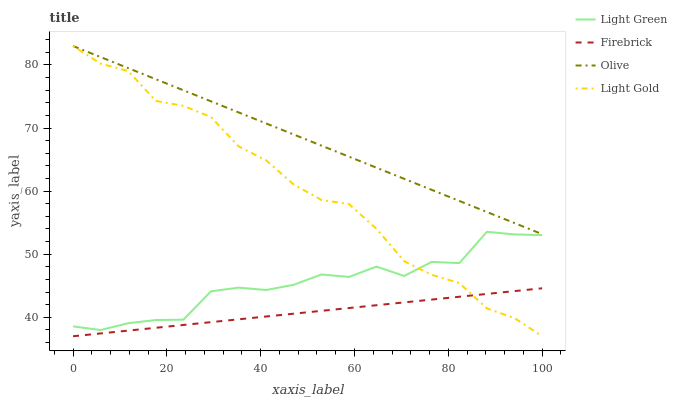Does Firebrick have the minimum area under the curve?
Answer yes or no. Yes. Does Olive have the maximum area under the curve?
Answer yes or no. Yes. Does Light Gold have the minimum area under the curve?
Answer yes or no. No. Does Light Gold have the maximum area under the curve?
Answer yes or no. No. Is Firebrick the smoothest?
Answer yes or no. Yes. Is Light Green the roughest?
Answer yes or no. Yes. Is Light Gold the smoothest?
Answer yes or no. No. Is Light Gold the roughest?
Answer yes or no. No. Does Firebrick have the lowest value?
Answer yes or no. Yes. Does Light Green have the lowest value?
Answer yes or no. No. Does Light Gold have the highest value?
Answer yes or no. Yes. Does Firebrick have the highest value?
Answer yes or no. No. Is Firebrick less than Olive?
Answer yes or no. Yes. Is Olive greater than Light Green?
Answer yes or no. Yes. Does Firebrick intersect Light Gold?
Answer yes or no. Yes. Is Firebrick less than Light Gold?
Answer yes or no. No. Is Firebrick greater than Light Gold?
Answer yes or no. No. Does Firebrick intersect Olive?
Answer yes or no. No. 